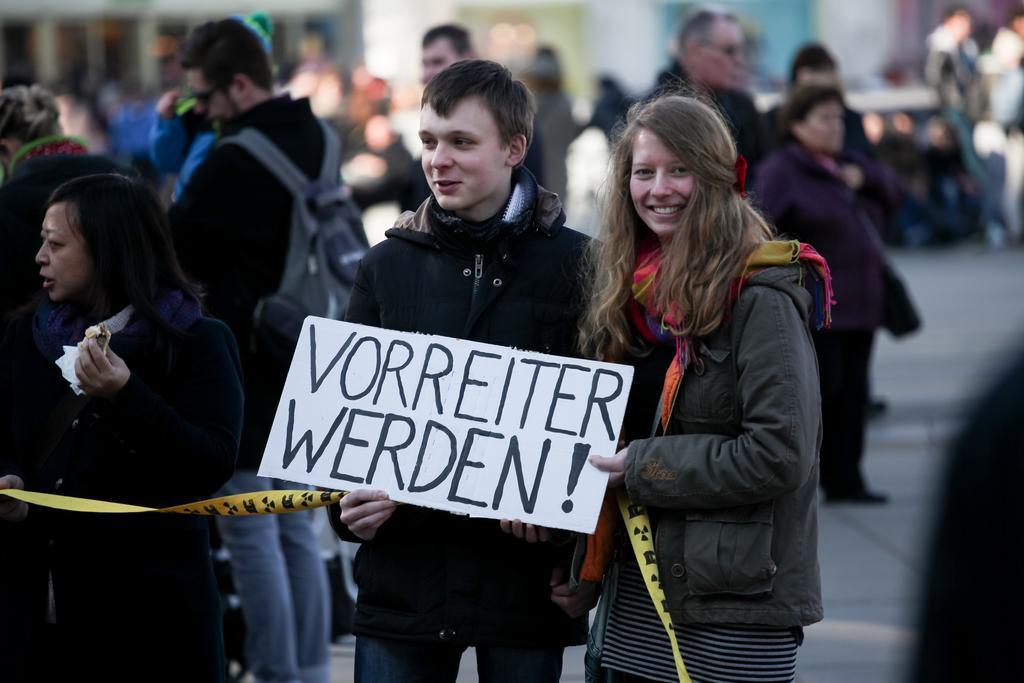Can you describe this image briefly? In the center of the image there are two people holding placard. In the background of the image there are many people. 